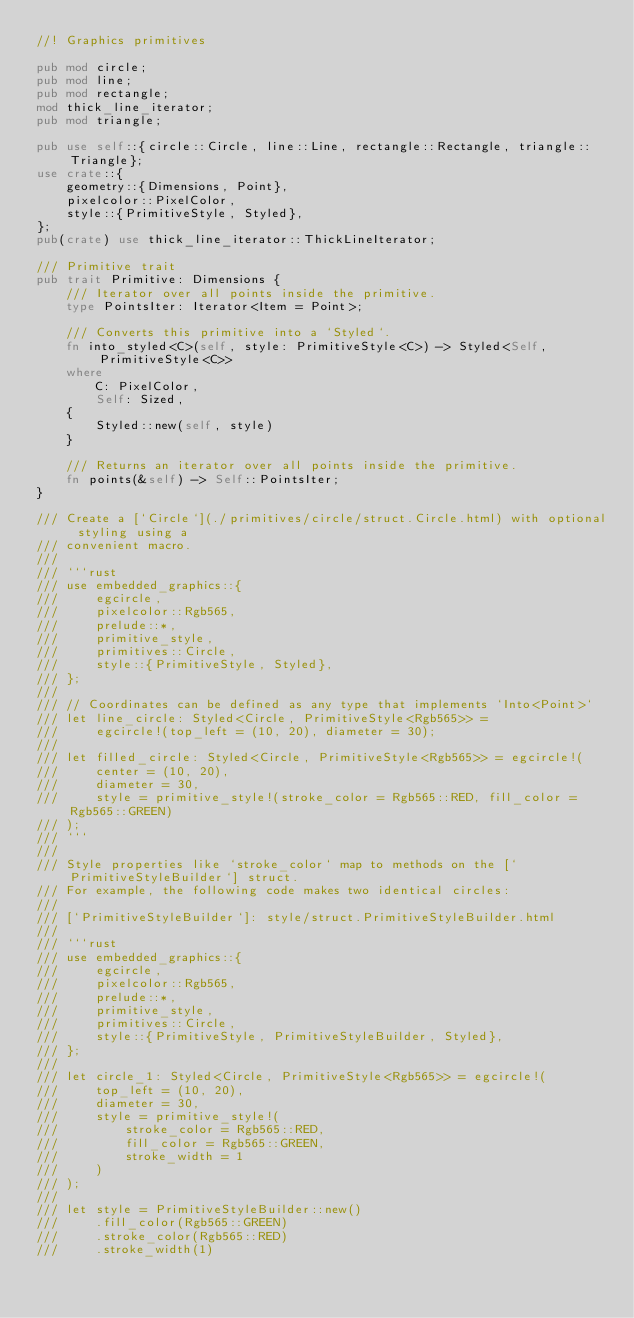Convert code to text. <code><loc_0><loc_0><loc_500><loc_500><_Rust_>//! Graphics primitives

pub mod circle;
pub mod line;
pub mod rectangle;
mod thick_line_iterator;
pub mod triangle;

pub use self::{circle::Circle, line::Line, rectangle::Rectangle, triangle::Triangle};
use crate::{
    geometry::{Dimensions, Point},
    pixelcolor::PixelColor,
    style::{PrimitiveStyle, Styled},
};
pub(crate) use thick_line_iterator::ThickLineIterator;

/// Primitive trait
pub trait Primitive: Dimensions {
    /// Iterator over all points inside the primitive.
    type PointsIter: Iterator<Item = Point>;

    /// Converts this primitive into a `Styled`.
    fn into_styled<C>(self, style: PrimitiveStyle<C>) -> Styled<Self, PrimitiveStyle<C>>
    where
        C: PixelColor,
        Self: Sized,
    {
        Styled::new(self, style)
    }

    /// Returns an iterator over all points inside the primitive.
    fn points(&self) -> Self::PointsIter;
}

/// Create a [`Circle`](./primitives/circle/struct.Circle.html) with optional styling using a
/// convenient macro.
///
/// ```rust
/// use embedded_graphics::{
///     egcircle,
///     pixelcolor::Rgb565,
///     prelude::*,
///     primitive_style,
///     primitives::Circle,
///     style::{PrimitiveStyle, Styled},
/// };
///
/// // Coordinates can be defined as any type that implements `Into<Point>`
/// let line_circle: Styled<Circle, PrimitiveStyle<Rgb565>> =
///     egcircle!(top_left = (10, 20), diameter = 30);
///
/// let filled_circle: Styled<Circle, PrimitiveStyle<Rgb565>> = egcircle!(
///     center = (10, 20),
///     diameter = 30,
///     style = primitive_style!(stroke_color = Rgb565::RED, fill_color = Rgb565::GREEN)
/// );
/// ```
///
/// Style properties like `stroke_color` map to methods on the [`PrimitiveStyleBuilder`] struct.
/// For example, the following code makes two identical circles:
///
/// [`PrimitiveStyleBuilder`]: style/struct.PrimitiveStyleBuilder.html
///
/// ```rust
/// use embedded_graphics::{
///     egcircle,
///     pixelcolor::Rgb565,
///     prelude::*,
///     primitive_style,
///     primitives::Circle,
///     style::{PrimitiveStyle, PrimitiveStyleBuilder, Styled},
/// };
///
/// let circle_1: Styled<Circle, PrimitiveStyle<Rgb565>> = egcircle!(
///     top_left = (10, 20),
///     diameter = 30,
///     style = primitive_style!(
///         stroke_color = Rgb565::RED,
///         fill_color = Rgb565::GREEN,
///         stroke_width = 1
///     )
/// );
///
/// let style = PrimitiveStyleBuilder::new()
///     .fill_color(Rgb565::GREEN)
///     .stroke_color(Rgb565::RED)
///     .stroke_width(1)</code> 